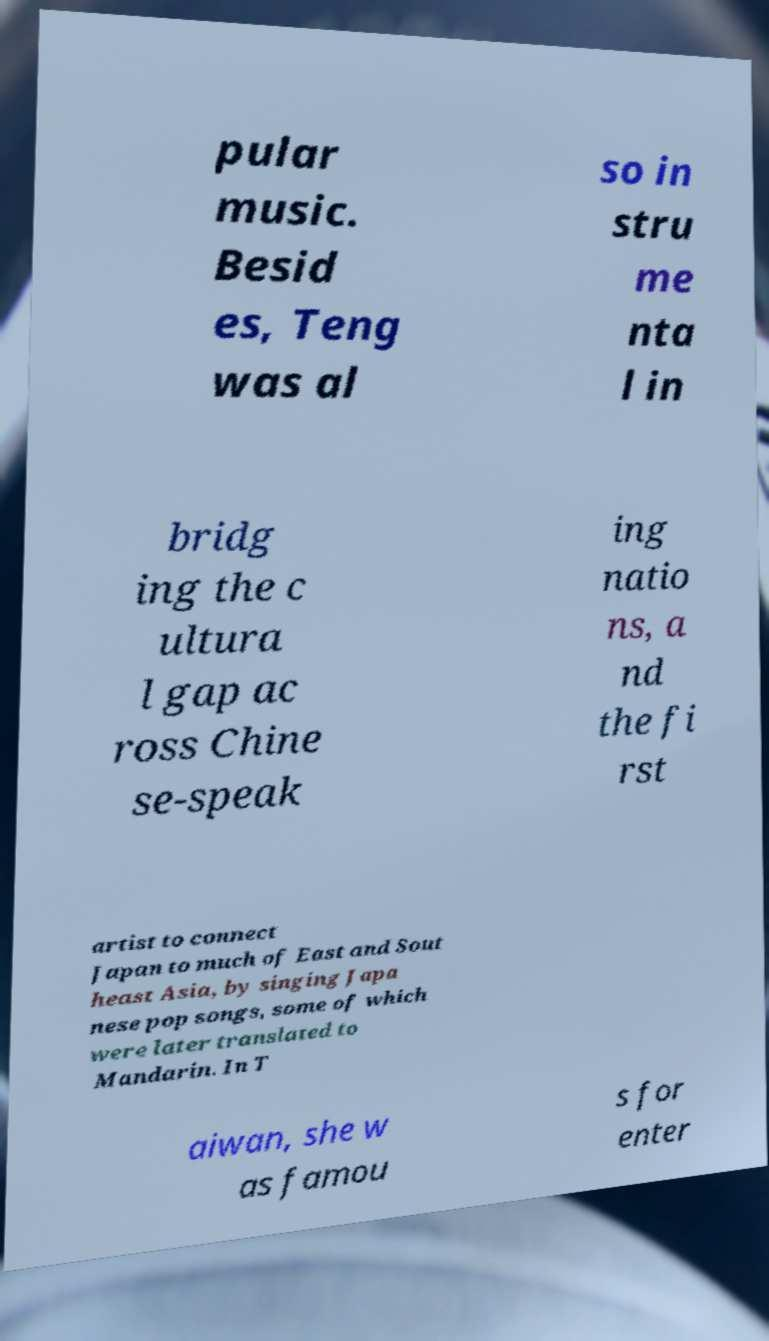Could you assist in decoding the text presented in this image and type it out clearly? pular music. Besid es, Teng was al so in stru me nta l in bridg ing the c ultura l gap ac ross Chine se-speak ing natio ns, a nd the fi rst artist to connect Japan to much of East and Sout heast Asia, by singing Japa nese pop songs, some of which were later translated to Mandarin. In T aiwan, she w as famou s for enter 